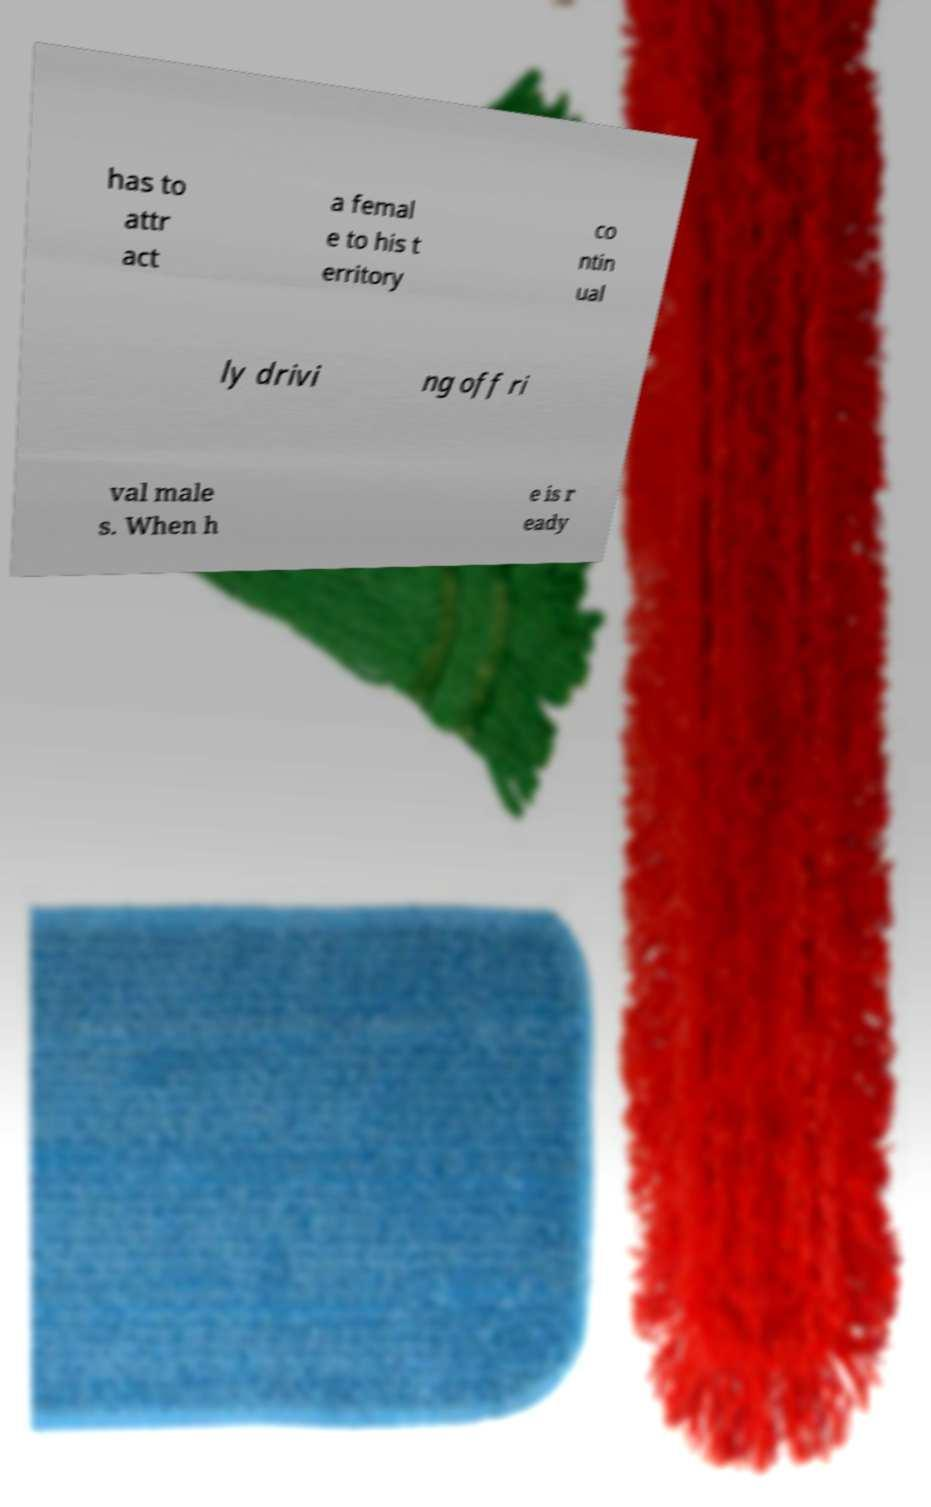What messages or text are displayed in this image? I need them in a readable, typed format. has to attr act a femal e to his t erritory co ntin ual ly drivi ng off ri val male s. When h e is r eady 